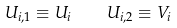Convert formula to latex. <formula><loc_0><loc_0><loc_500><loc_500>U _ { i , 1 } \equiv U _ { i } \quad U _ { i , 2 } \equiv V _ { i }</formula> 